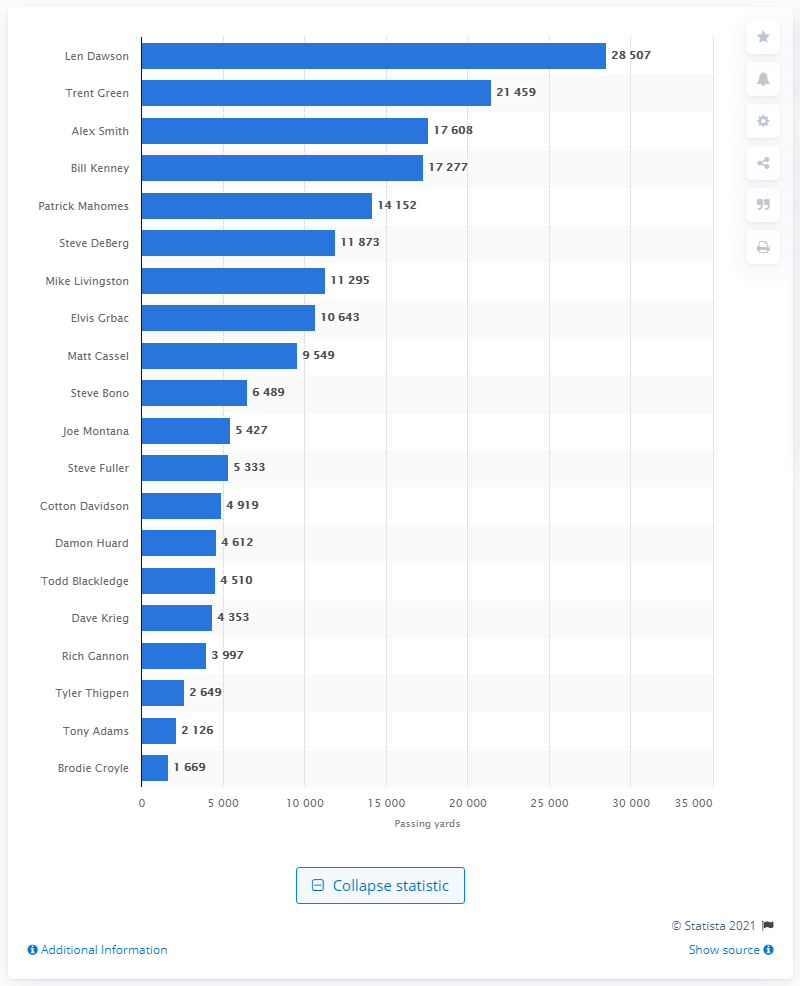Specify some key components in this picture. The person who leads in career passing for the Kansas City Chiefs is Len Dawson. 